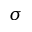<formula> <loc_0><loc_0><loc_500><loc_500>\sigma</formula> 